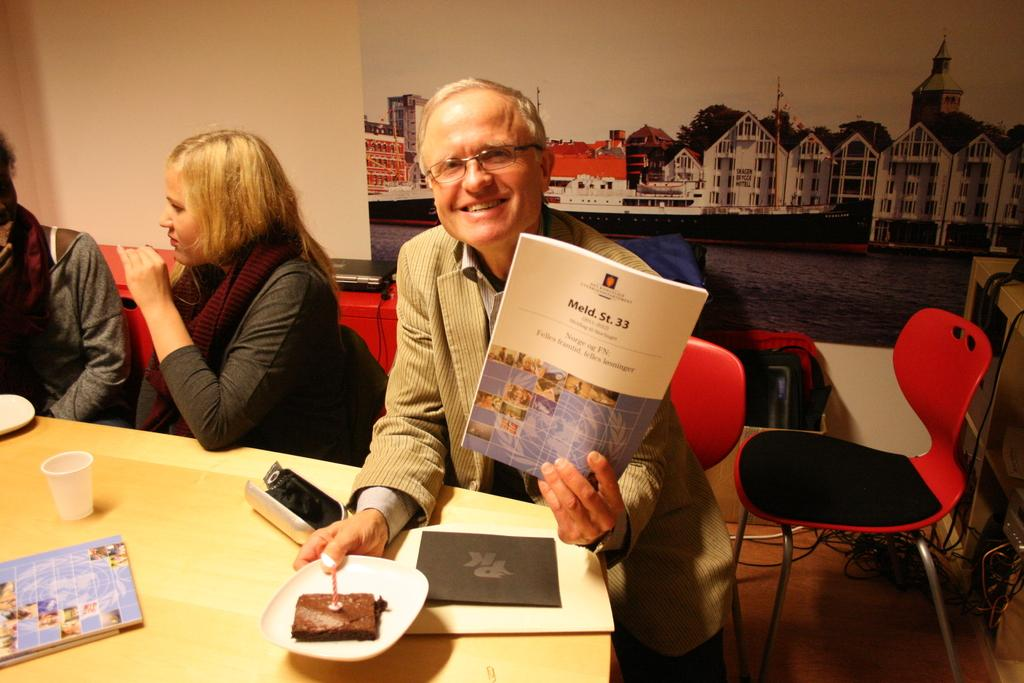What is the man in the image holding? The man is holding a book. What is the man's position in the image? The man is sitting on a chair. Where is the chair located in relation to the table? The chair is in front of a table. What else can be seen on the table besides the paper? There is a glass on the table. How many other people are in the image besides the man? There are two other people in the image. What type of needle is the governor using in the image? There is no governor or needle present in the image. 